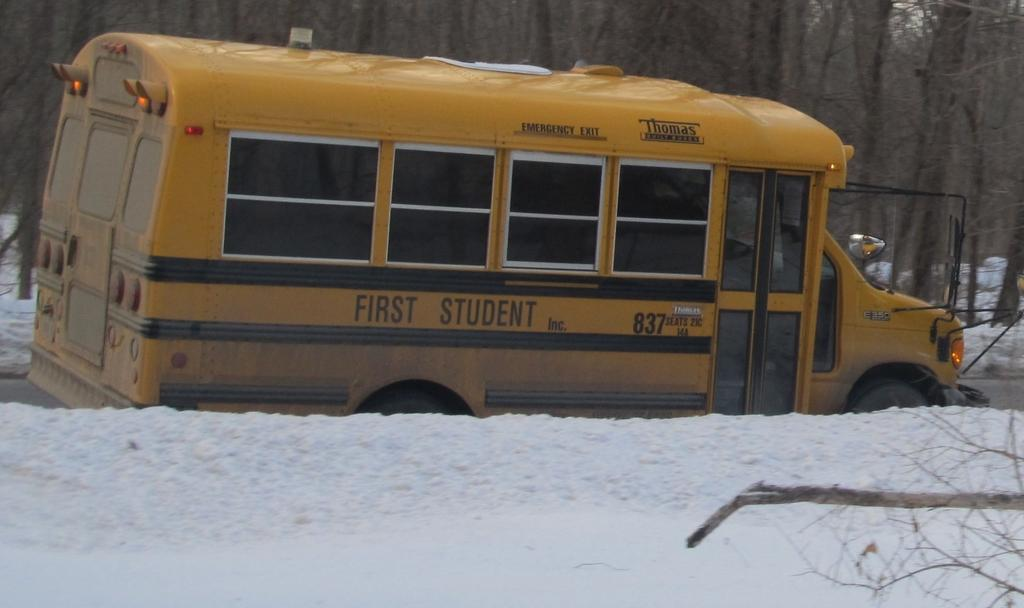<image>
Write a terse but informative summary of the picture. A short yellow bus from First Student numbered 837. 